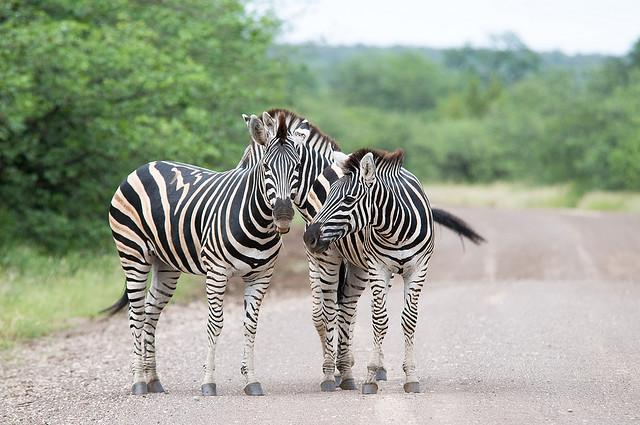What part of this photo would these animals never encounter in their natural habitat? road 